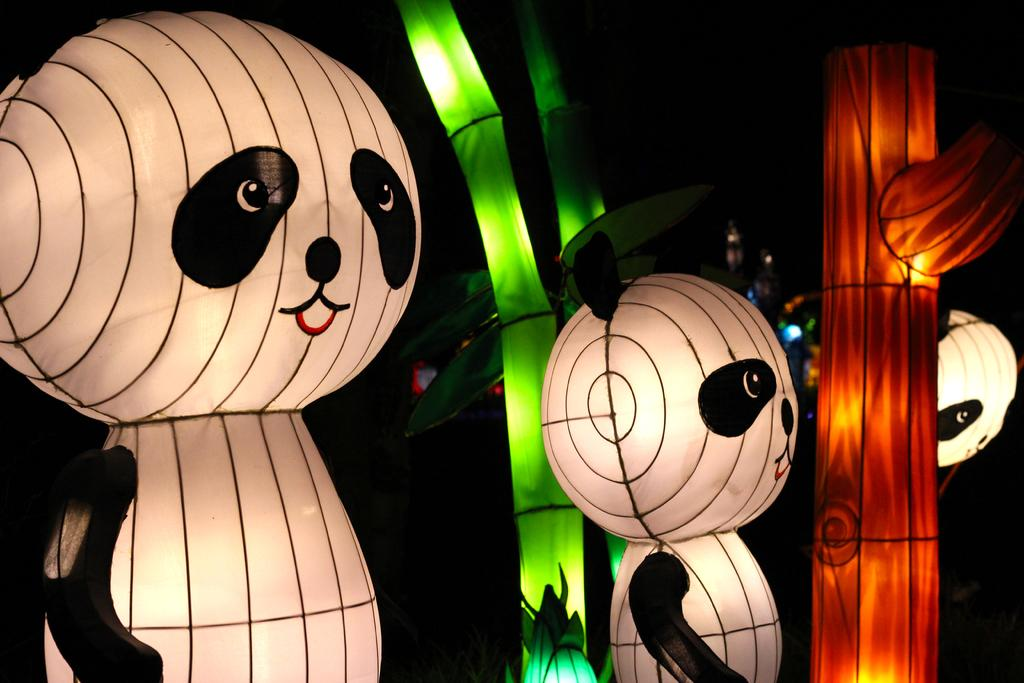What type of objects are featured in the image? There are inflatable mascots in the image. What else can be seen in the image besides the mascots? There are lights visible in the image. Can you describe the background of the image? The background of the image is dark. How much money is being exchanged between the mascots in the image? There is no money being exchanged in the image, as it features inflatable mascots and lights. 